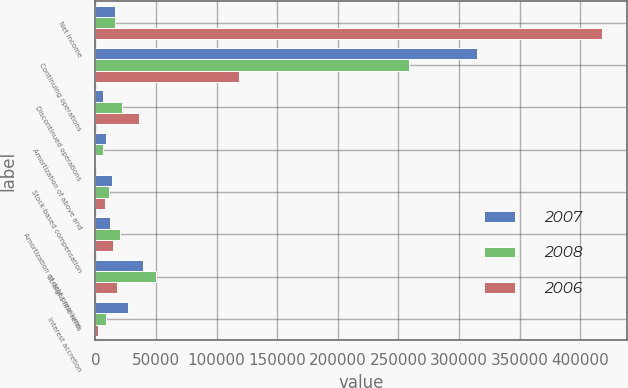Convert chart to OTSL. <chart><loc_0><loc_0><loc_500><loc_500><stacked_bar_chart><ecel><fcel>Net income<fcel>Continuing operations<fcel>Discontinued operations<fcel>Amortization of above and<fcel>Stock-based compensation<fcel>Amortization of debt premiums<fcel>Straight-line rents<fcel>Interest accretion<nl><fcel>2007<fcel>16371.5<fcel>314632<fcel>6604<fcel>8440<fcel>13765<fcel>12267<fcel>39463<fcel>27019<nl><fcel>2008<fcel>16371.5<fcel>258947<fcel>22232<fcel>6056<fcel>11408<fcel>20413<fcel>49725<fcel>8739<nl><fcel>2006<fcel>417547<fcel>118393<fcel>35676<fcel>797<fcel>8232<fcel>14533<fcel>18210<fcel>2513<nl></chart> 